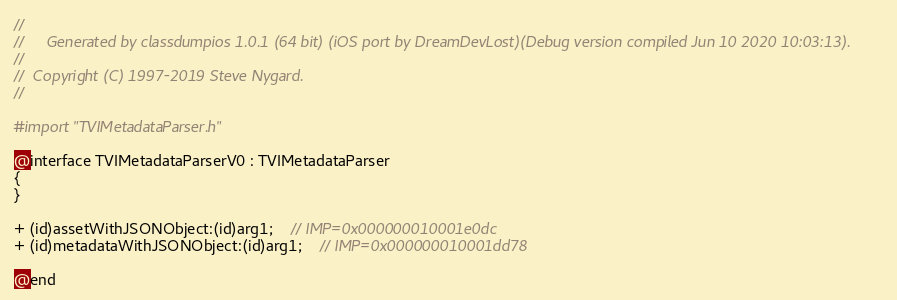<code> <loc_0><loc_0><loc_500><loc_500><_C_>//
//     Generated by classdumpios 1.0.1 (64 bit) (iOS port by DreamDevLost)(Debug version compiled Jun 10 2020 10:03:13).
//
//  Copyright (C) 1997-2019 Steve Nygard.
//

#import "TVIMetadataParser.h"

@interface TVIMetadataParserV0 : TVIMetadataParser
{
}

+ (id)assetWithJSONObject:(id)arg1;	// IMP=0x000000010001e0dc
+ (id)metadataWithJSONObject:(id)arg1;	// IMP=0x000000010001dd78

@end

</code> 